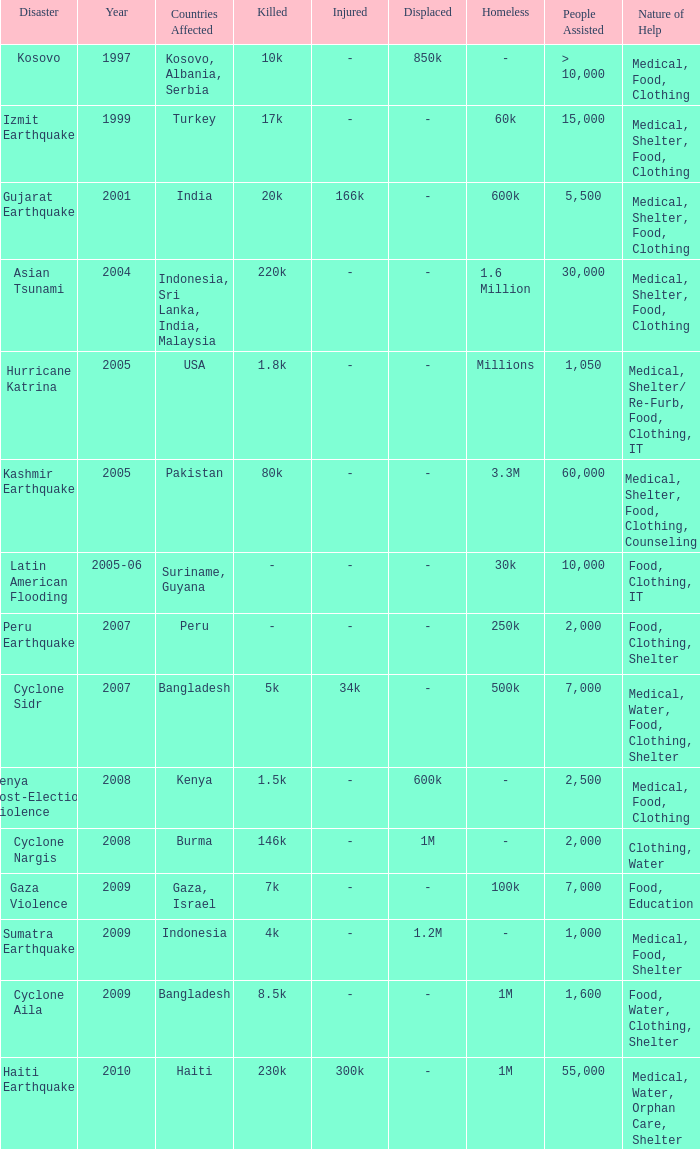What is the scale of disaster for the USA? 1.8k killed, Millions homeless. 